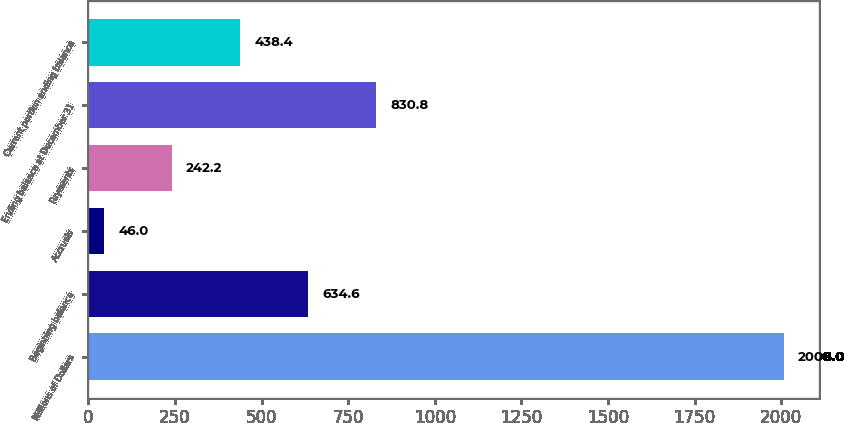<chart> <loc_0><loc_0><loc_500><loc_500><bar_chart><fcel>Millions of Dollars<fcel>Beginning balance<fcel>Accruals<fcel>Payments<fcel>Ending balance at December 31<fcel>Current portion ending balance<nl><fcel>2008<fcel>634.6<fcel>46<fcel>242.2<fcel>830.8<fcel>438.4<nl></chart> 